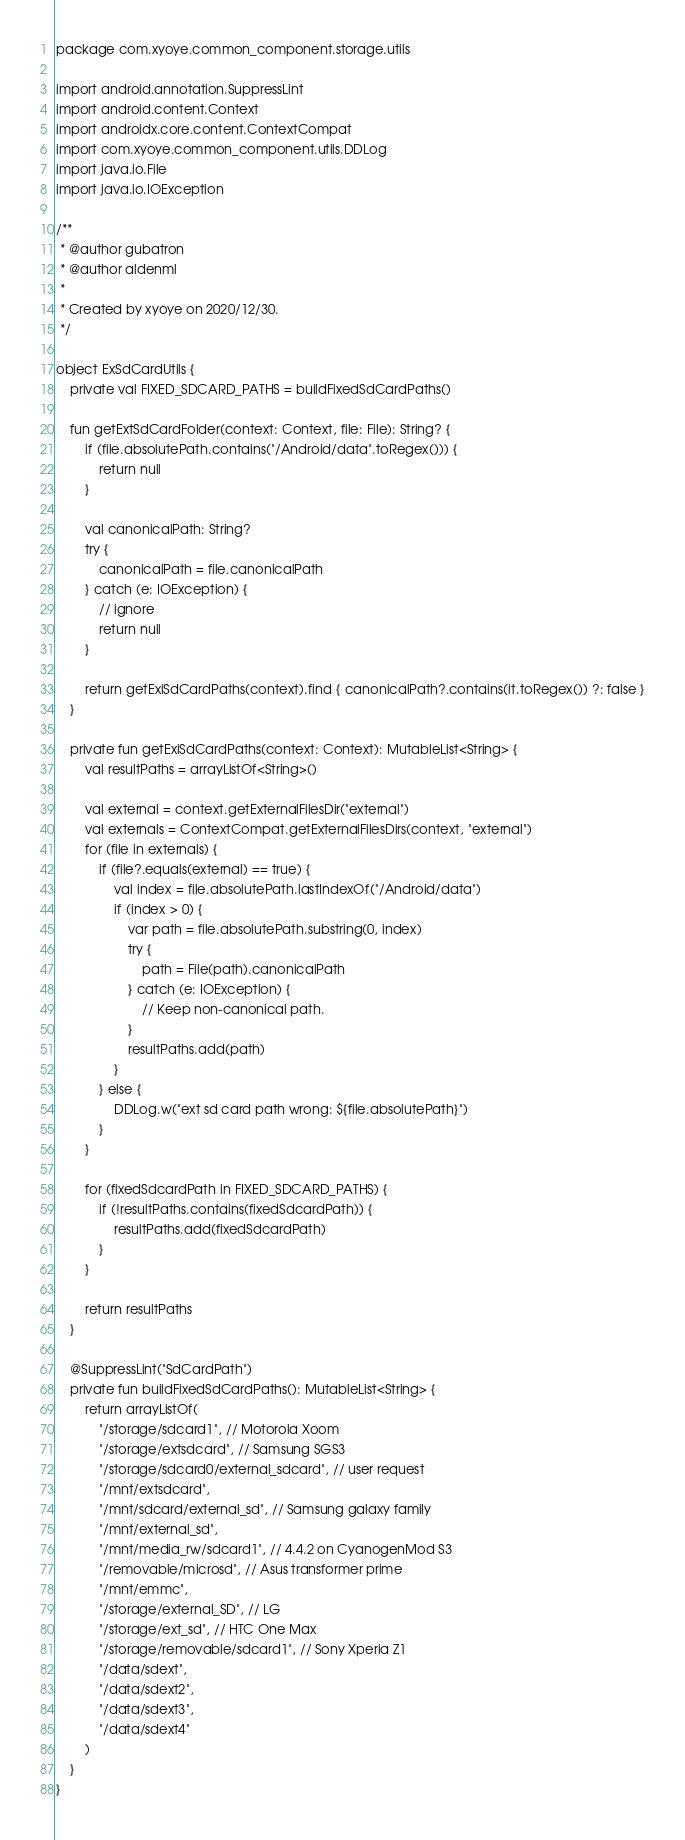<code> <loc_0><loc_0><loc_500><loc_500><_Kotlin_>package com.xyoye.common_component.storage.utils

import android.annotation.SuppressLint
import android.content.Context
import androidx.core.content.ContextCompat
import com.xyoye.common_component.utils.DDLog
import java.io.File
import java.io.IOException

/**
 * @author gubatron
 * @author aldenml
 *
 * Created by xyoye on 2020/12/30.
 */

object ExSdCardUtils {
    private val FIXED_SDCARD_PATHS = buildFixedSdCardPaths()

    fun getExtSdCardFolder(context: Context, file: File): String? {
        if (file.absolutePath.contains("/Android/data".toRegex())) {
            return null
        }

        val canonicalPath: String?
        try {
            canonicalPath = file.canonicalPath
        } catch (e: IOException) {
            // ignore
            return null
        }

        return getExiSdCardPaths(context).find { canonicalPath?.contains(it.toRegex()) ?: false }
    }

    private fun getExiSdCardPaths(context: Context): MutableList<String> {
        val resultPaths = arrayListOf<String>()

        val external = context.getExternalFilesDir("external")
        val externals = ContextCompat.getExternalFilesDirs(context, "external")
        for (file in externals) {
            if (file?.equals(external) == true) {
                val index = file.absolutePath.lastIndexOf("/Android/data")
                if (index > 0) {
                    var path = file.absolutePath.substring(0, index)
                    try {
                        path = File(path).canonicalPath
                    } catch (e: IOException) {
                        // Keep non-canonical path.
                    }
                    resultPaths.add(path)
                }
            } else {
                DDLog.w("ext sd card path wrong: ${file.absolutePath}")
            }
        }

        for (fixedSdcardPath in FIXED_SDCARD_PATHS) {
            if (!resultPaths.contains(fixedSdcardPath)) {
                resultPaths.add(fixedSdcardPath)
            }
        }

        return resultPaths
    }

    @SuppressLint("SdCardPath")
    private fun buildFixedSdCardPaths(): MutableList<String> {
        return arrayListOf(
            "/storage/sdcard1", // Motorola Xoom
            "/storage/extsdcard", // Samsung SGS3
            "/storage/sdcard0/external_sdcard", // user request
            "/mnt/extsdcard",
            "/mnt/sdcard/external_sd", // Samsung galaxy family
            "/mnt/external_sd",
            "/mnt/media_rw/sdcard1", // 4.4.2 on CyanogenMod S3
            "/removable/microsd", // Asus transformer prime
            "/mnt/emmc",
            "/storage/external_SD", // LG
            "/storage/ext_sd", // HTC One Max
            "/storage/removable/sdcard1", // Sony Xperia Z1
            "/data/sdext",
            "/data/sdext2",
            "/data/sdext3",
            "/data/sdext4"
        )
    }
}</code> 